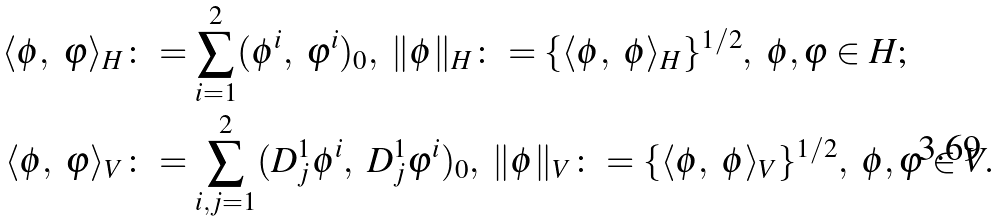Convert formula to latex. <formula><loc_0><loc_0><loc_500><loc_500>\langle \phi , \ \varphi \rangle _ { H } \colon & = \sum _ { i = 1 } ^ { 2 } ( \phi ^ { i } , \ \varphi ^ { i } ) _ { 0 } , \ \| \phi \| _ { H } \colon = \{ \langle \phi , \ \phi \rangle _ { H } \} ^ { 1 / 2 } , \ \phi , \varphi \in H ; \\ \langle \phi , \ \varphi \rangle _ { V } \colon & = \sum _ { i , j = 1 } ^ { 2 } ( D _ { j } ^ { 1 } \phi ^ { i } , \ D _ { j } ^ { 1 } \varphi ^ { i } ) _ { 0 } , \ \| \phi \| _ { V } \colon = \{ \langle \phi , \ \phi \rangle _ { V } \} ^ { 1 / 2 } , \ \phi , \varphi \in V .</formula> 